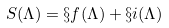<formula> <loc_0><loc_0><loc_500><loc_500>S ( \Lambda ) = \S f ( \Lambda ) + \S i ( \Lambda )</formula> 